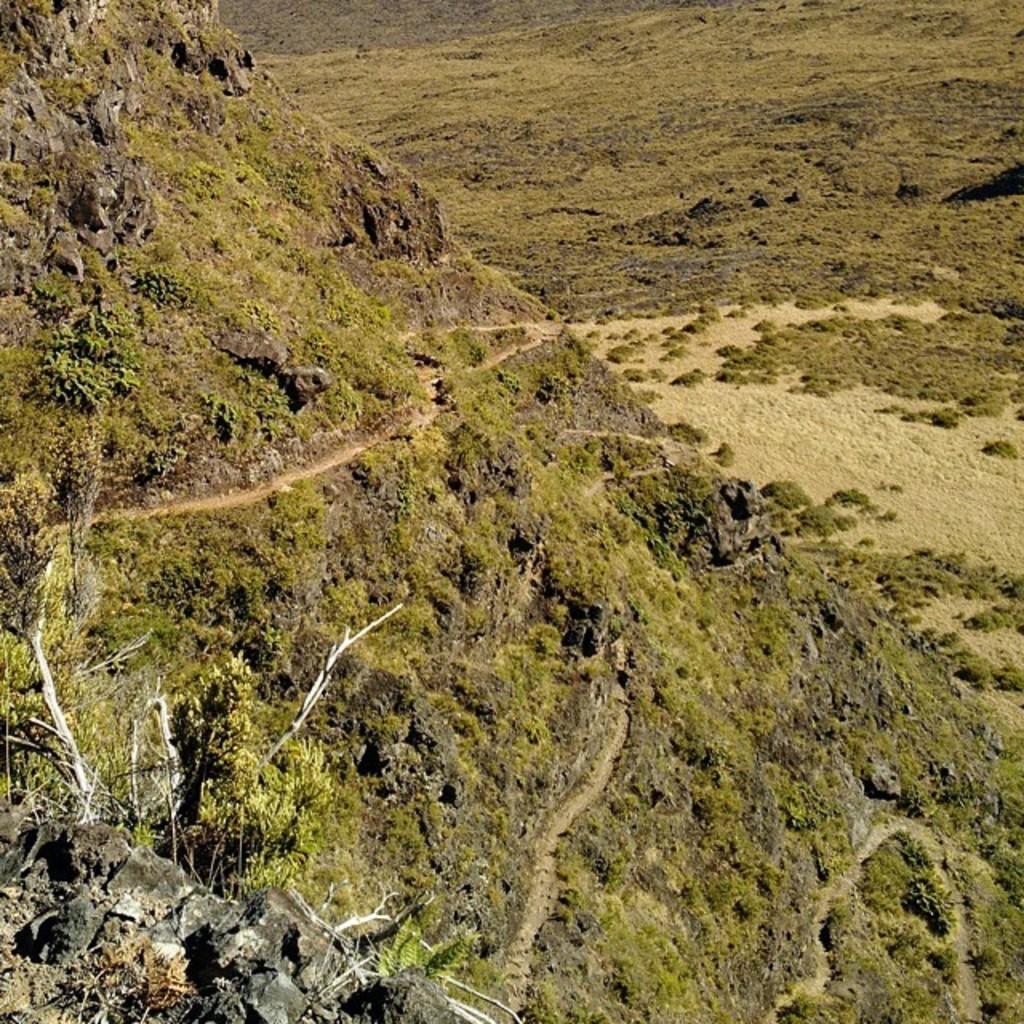Please provide a concise description of this image. At the bottom of the image we can see trees. In the background there are hills. 